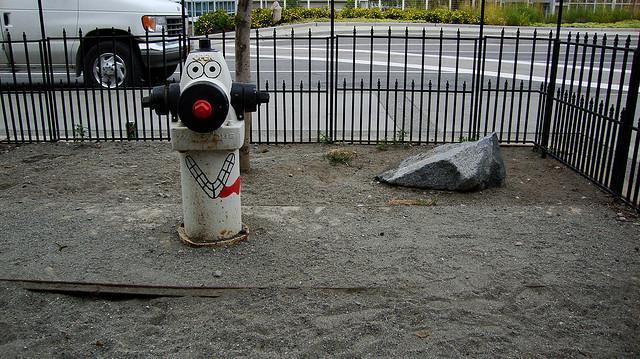How many people are cutting cake?
Give a very brief answer. 0. 